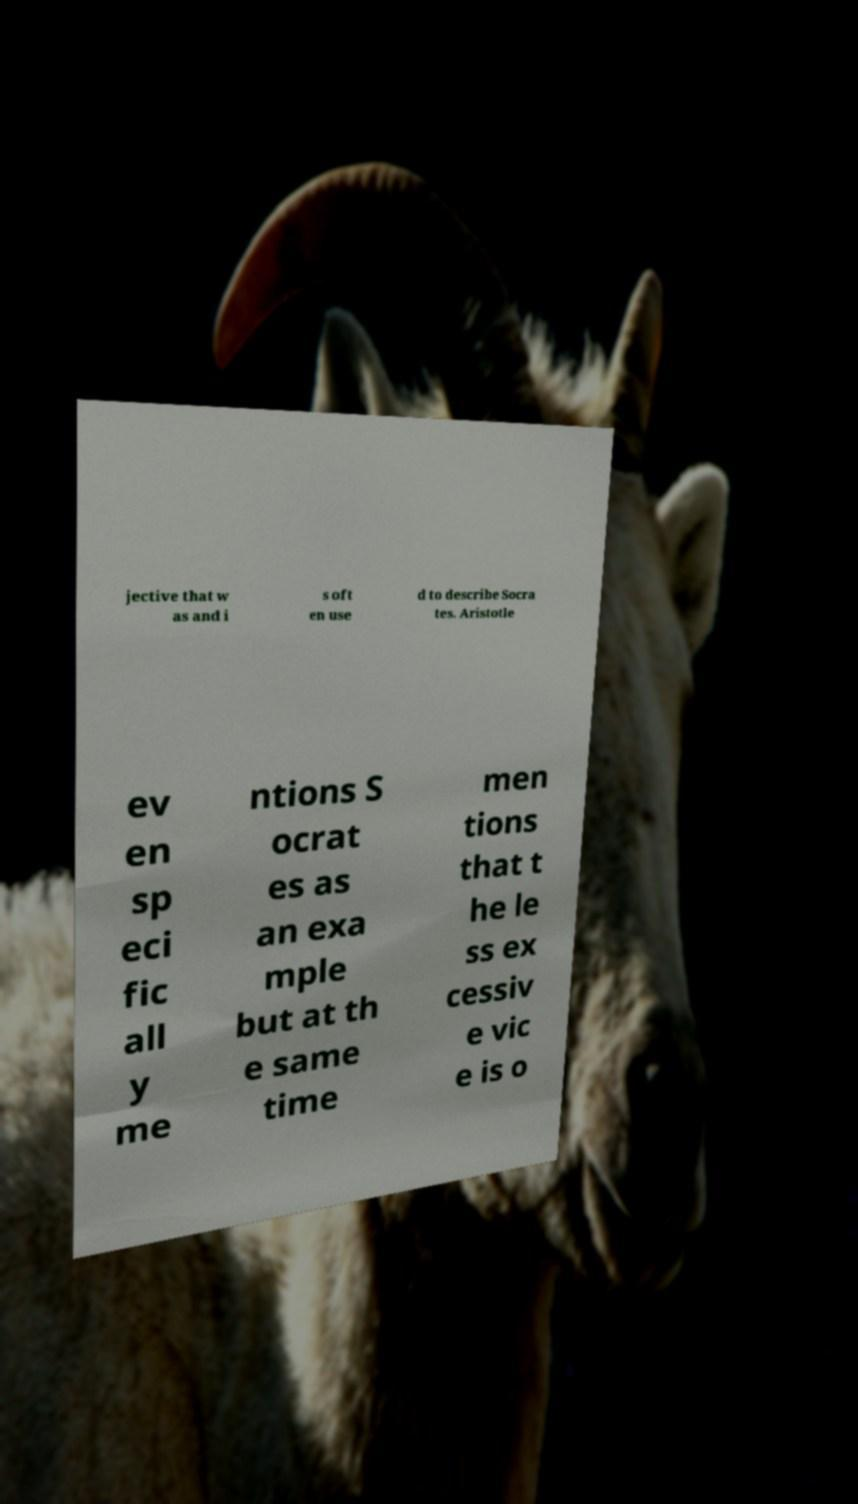There's text embedded in this image that I need extracted. Can you transcribe it verbatim? jective that w as and i s oft en use d to describe Socra tes. Aristotle ev en sp eci fic all y me ntions S ocrat es as an exa mple but at th e same time men tions that t he le ss ex cessiv e vic e is o 